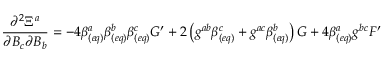<formula> <loc_0><loc_0><loc_500><loc_500>\frac { \partial ^ { 2 } \Xi ^ { a } } { \partial B _ { c } \partial B _ { b } } = - 4 \beta _ { ( e q ) } ^ { a } \beta _ { ( e q ) } ^ { b } \beta _ { ( e q ) } ^ { c } G ^ { \prime } + 2 \left ( g ^ { a b } \beta _ { ( e q ) } ^ { c } + g ^ { a c } \beta _ { ( e q ) } ^ { b } \right ) G + 4 \beta _ { ( e q ) } ^ { a } g ^ { b c } F ^ { \prime }</formula> 